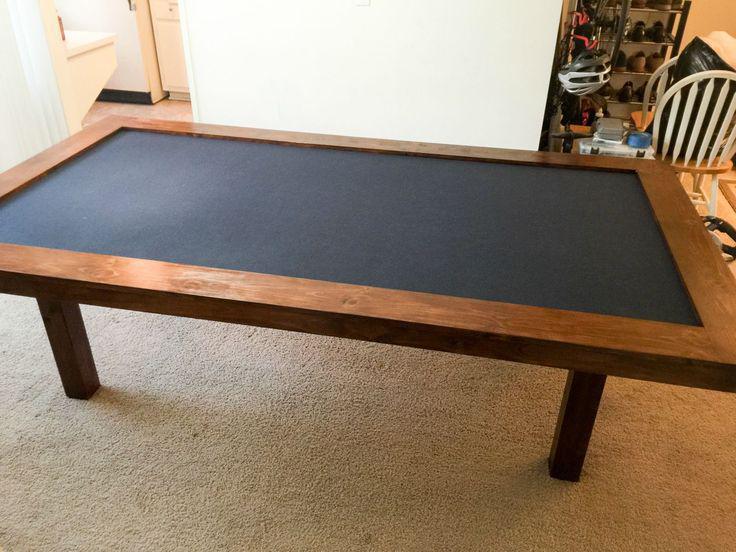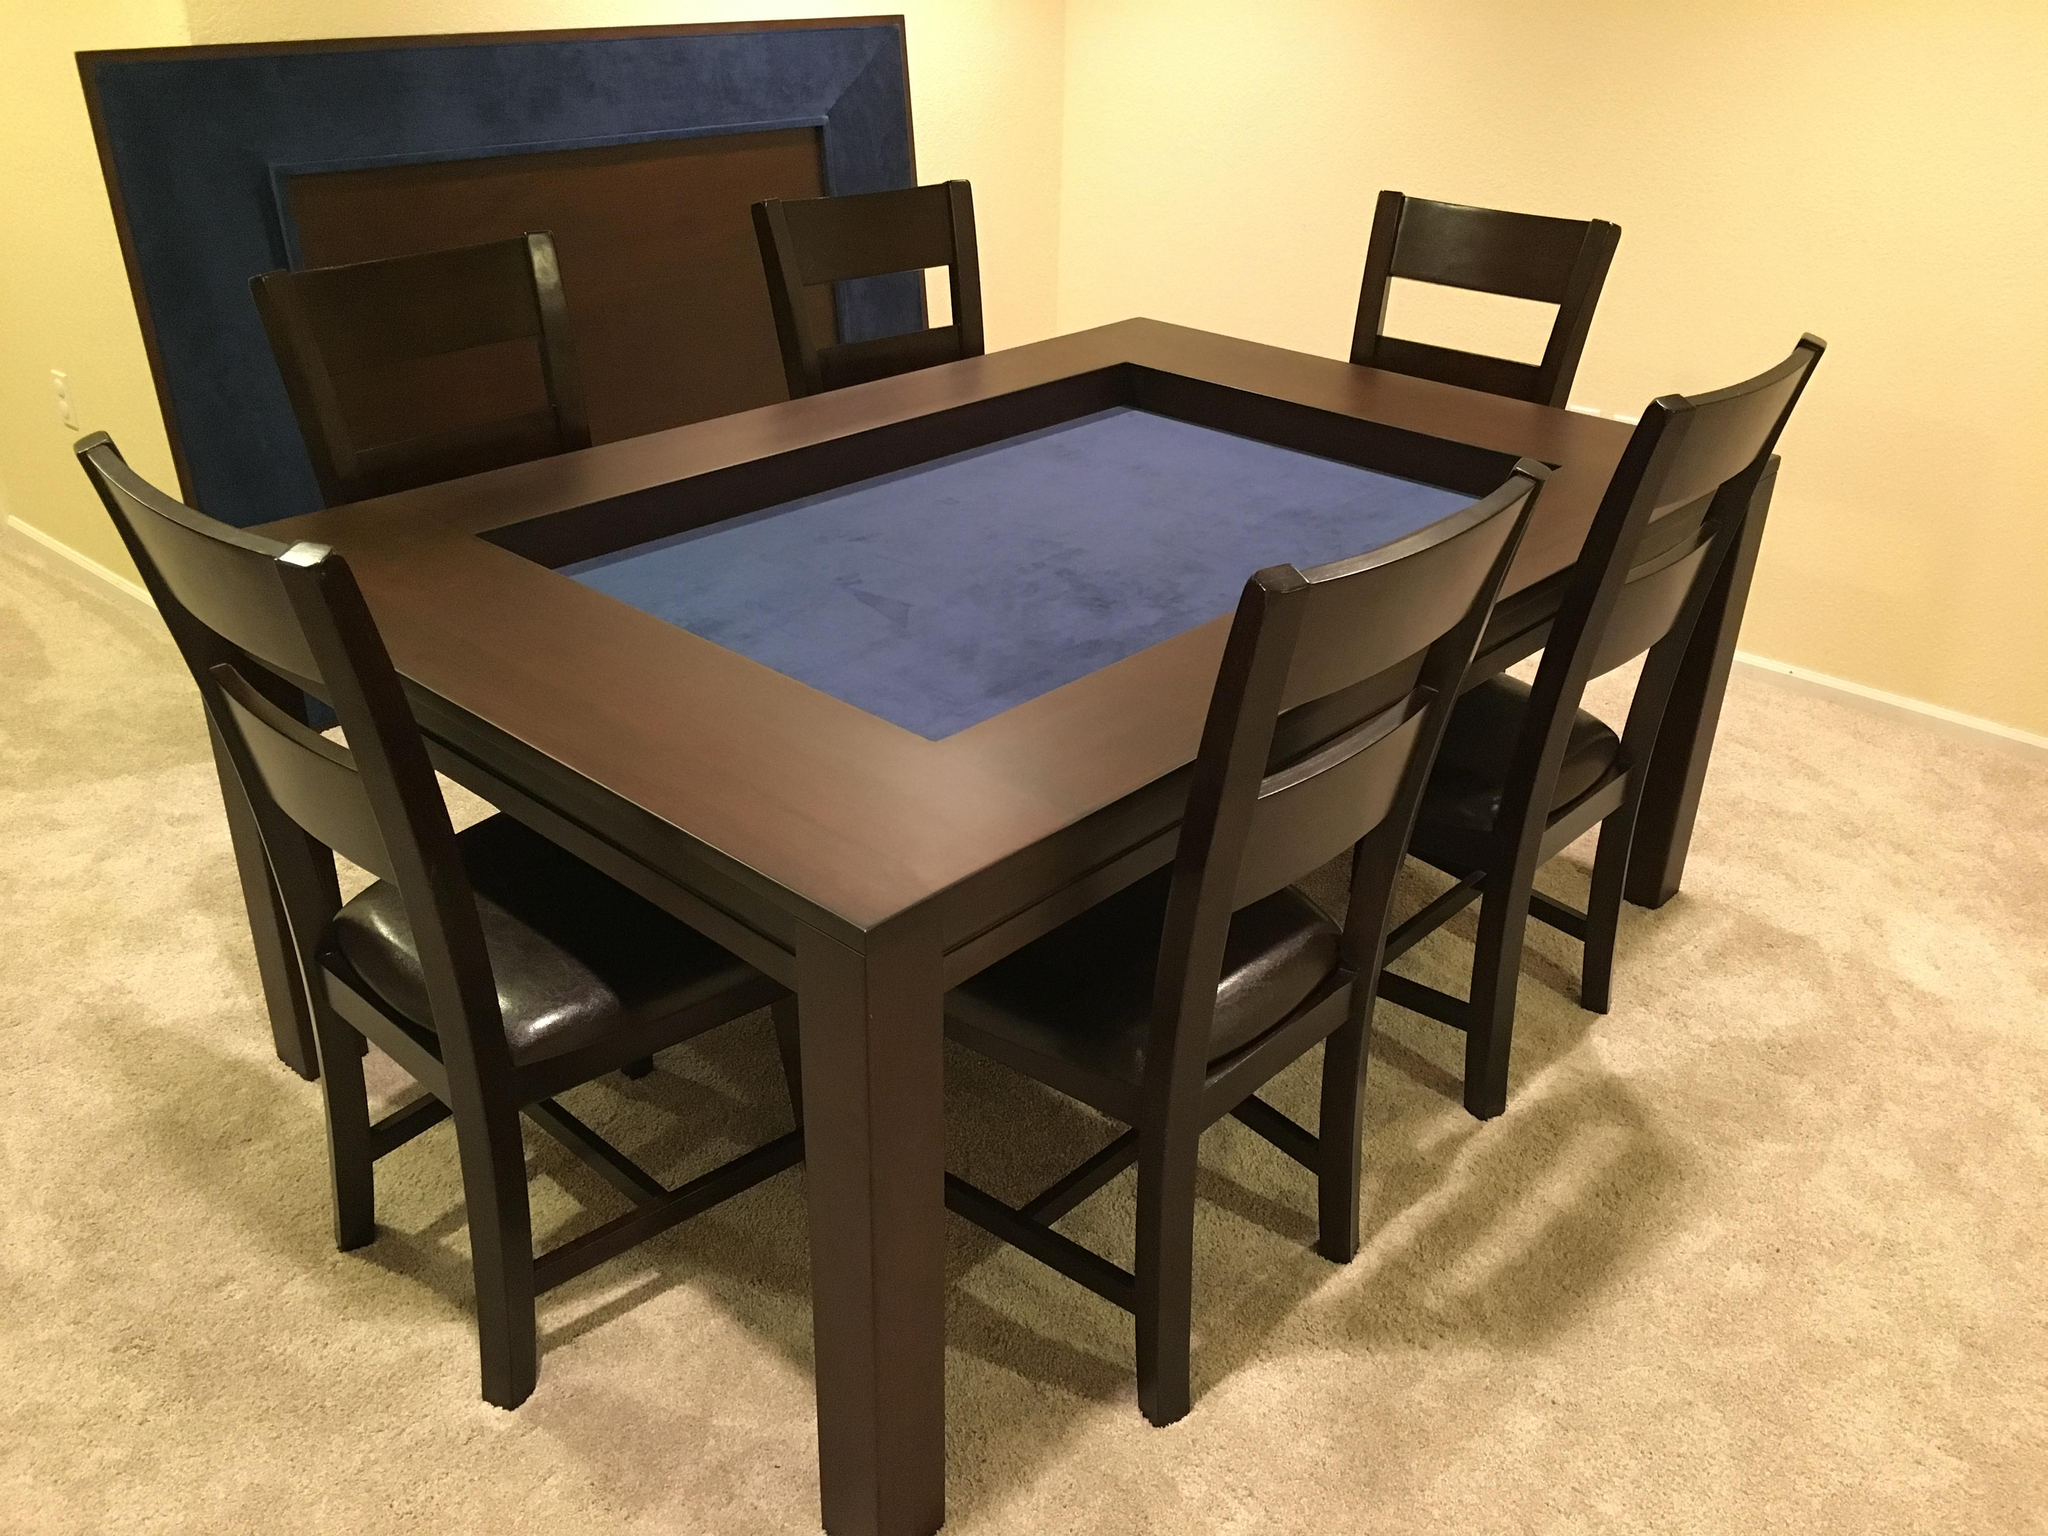The first image is the image on the left, the second image is the image on the right. Analyze the images presented: Is the assertion "In one image, a rectangular table has chairs at each side and at each end." valid? Answer yes or no. Yes. The first image is the image on the left, the second image is the image on the right. Examine the images to the left and right. Is the description "An image shows a rectangular table with wood border, charcoal center, and no chairs." accurate? Answer yes or no. Yes. 